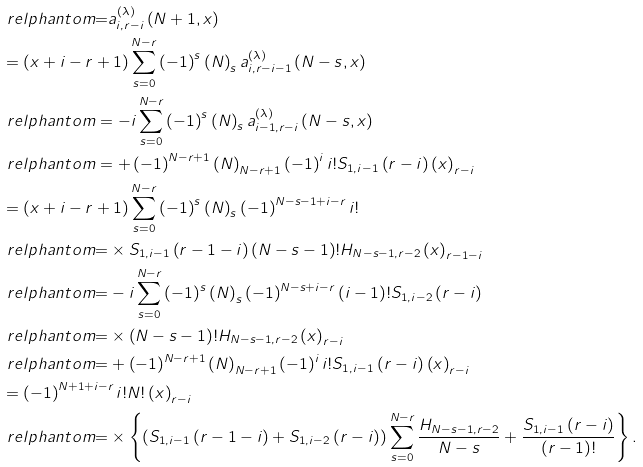Convert formula to latex. <formula><loc_0><loc_0><loc_500><loc_500>& \ r e l p h a n t o m { = } a _ { i , r - i } ^ { \left ( \lambda \right ) } \left ( N + 1 , x \right ) \\ & = \left ( x + i - r + 1 \right ) \sum _ { s = 0 } ^ { N - r } \left ( - 1 \right ) ^ { s } \left ( N \right ) _ { s } a _ { i , r - i - 1 } ^ { \left ( \lambda \right ) } \left ( N - s , x \right ) \\ & \ r e l p h a n t o m = - i \sum _ { s = 0 } ^ { N - r } \left ( - 1 \right ) ^ { s } \left ( N \right ) _ { s } a _ { i - 1 , r - i } ^ { \left ( \lambda \right ) } \left ( N - s , x \right ) \\ & \ r e l p h a n t o m = + \left ( - 1 \right ) ^ { N - r + 1 } \left ( N \right ) _ { N - r + 1 } \left ( - 1 \right ) ^ { i } i ! S _ { 1 , i - 1 } \left ( r - i \right ) \left ( x \right ) _ { r - i } \\ & = \left ( x + i - r + 1 \right ) \sum _ { s = 0 } ^ { N - r } \left ( - 1 \right ) ^ { s } \left ( N \right ) _ { s } \left ( - 1 \right ) ^ { N - s - 1 + i - r } i ! \\ & \ r e l p h a n t o m { = } \times S _ { 1 , i - 1 } \left ( r - 1 - i \right ) \left ( N - s - 1 \right ) ! H _ { N - s - 1 , r - 2 } \left ( x \right ) _ { r - 1 - i } \\ & \ r e l p h a n t o m { = } - i \sum _ { s = 0 } ^ { N - r } \left ( - 1 \right ) ^ { s } \left ( N \right ) _ { s } \left ( - 1 \right ) ^ { N - s + i - r } \left ( i - 1 \right ) ! S _ { 1 , i - 2 } \left ( r - i \right ) \\ & \ r e l p h a n t o m { = } \times \left ( N - s - 1 \right ) ! H _ { N - s - 1 , r - 2 } \left ( x \right ) _ { r - i } \\ & \ r e l p h a n t o m { = } + \left ( - 1 \right ) ^ { N - r + 1 } \left ( N \right ) _ { N - r + 1 } \left ( - 1 \right ) ^ { i } i ! S _ { 1 , i - 1 } \left ( r - i \right ) \left ( x \right ) _ { r - i } \\ & = \left ( - 1 \right ) ^ { N + 1 + i - r } i ! N ! \left ( x \right ) _ { r - i } \\ & \ r e l p h a n t o m { = } \times \left \{ \left ( S _ { 1 , i - 1 } \left ( r - 1 - i \right ) + S _ { 1 , i - 2 } \left ( r - i \right ) \right ) \sum _ { s = 0 } ^ { N - r } \frac { H _ { N - s - 1 , r - 2 } } { N - s } + \frac { S _ { 1 , i - 1 } \left ( r - i \right ) } { \left ( r - 1 \right ) ! } \right \} .</formula> 